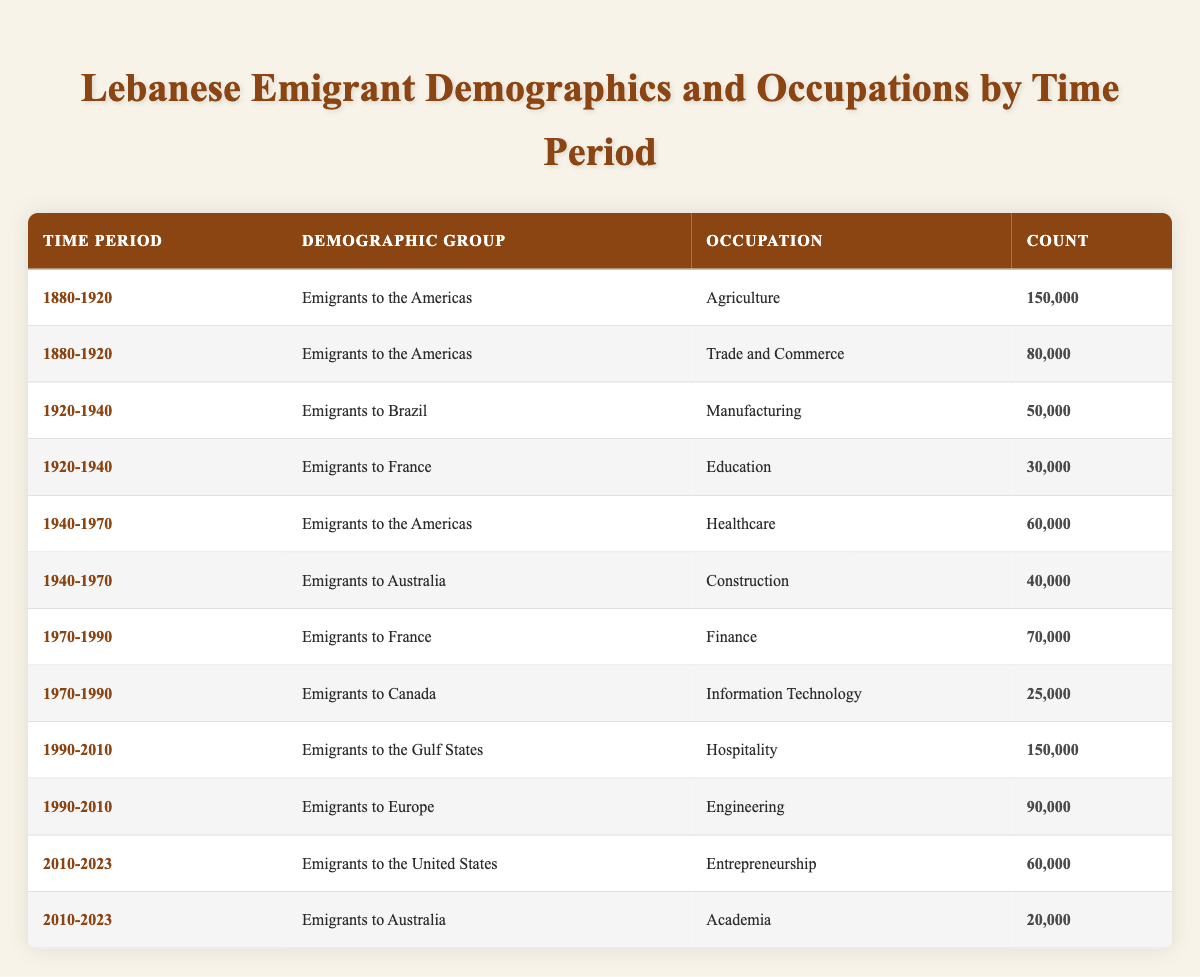What was the dominant occupation for Lebanese emigrants to the Americas between 1880 and 1920? The table shows that during the time period of 1880-1920, the dominant occupation for Lebanese emigrants to the Americas was Agriculture, with a count of 150,000.
Answer: Agriculture How many emigrants to Australia worked in Construction between 1940 and 1970? The table indicates that during the 1940-1970 period, there were 40,000 emigrants to Australia who worked in Construction.
Answer: 40,000 Is it true that more Lebanese emigrants went into Hospitality during the period of 1990-2010 than those who worked in Engineering? Yes, the table shows that 150,000 Lebanese emigrants worked in Hospitality while only 90,000 were in Engineering during the 1990-2010 period, confirming the statement is true.
Answer: Yes What is the total count of Lebanese emigrants in the Healthcare occupation in the 1940-1970 period? According to the table, there were 60,000 Lebanese emigrants in the Healthcare occupation during the 1940-1970 period.
Answer: 60,000 Which time period had the highest recorded occupation count for emigrants to the Gulf States? The table reveals that the time period from 1990-2010 had the highest recorded occupation count for emigrants to the Gulf States with a total of 150,000 in Hospitality.
Answer: 1990-2010 What were the occupations of Lebanese emigrants to France in the 1970-1990 period and their combined count? The table lists Finance as the occupation for Lebanese emigrants to France in this period with a count of 70,000. Since it is the only occupation listed, the combined count remains 70,000.
Answer: Finance; 70,000 How does the count of emigrants working in Trade and Commerce during 1880-1920 compare to those in Information Technology from 1970-1990? The table shows that 80,000 Lebanese emigrants worked in Trade and Commerce during 1880-1920, while 25,000 were in Information Technology from 1970-1990. This indicates that more emigrants worked in Trade and Commerce by a difference of 55,000.
Answer: More by 55,000 What percentage of Lebanese emigrants to the Americas were involved in Agriculture and Trade and Commerce combined during the 1880-1920 period? The combined count for Agriculture (150,000) and Trade and Commerce (80,000) is 230,000. To find the percentage, considering only wants the count of emigrants to the Americas, we use the total of 230,000 over the counts from the 1880-1920 period. Assuming the total is the sum of available counts from the mentioned categories, we see that 230,000 is equal to the total for the Americas out of 230,000. Hence, the percentage is 100%.
Answer: 100% What was the occupation focus of Lebanese emigrants to Australia from 2010 to 2023? The table shows that during the 2010-2023 period, Lebanese emigrants to Australia had a focus on Academia, with a count of 20,000.
Answer: Academia 